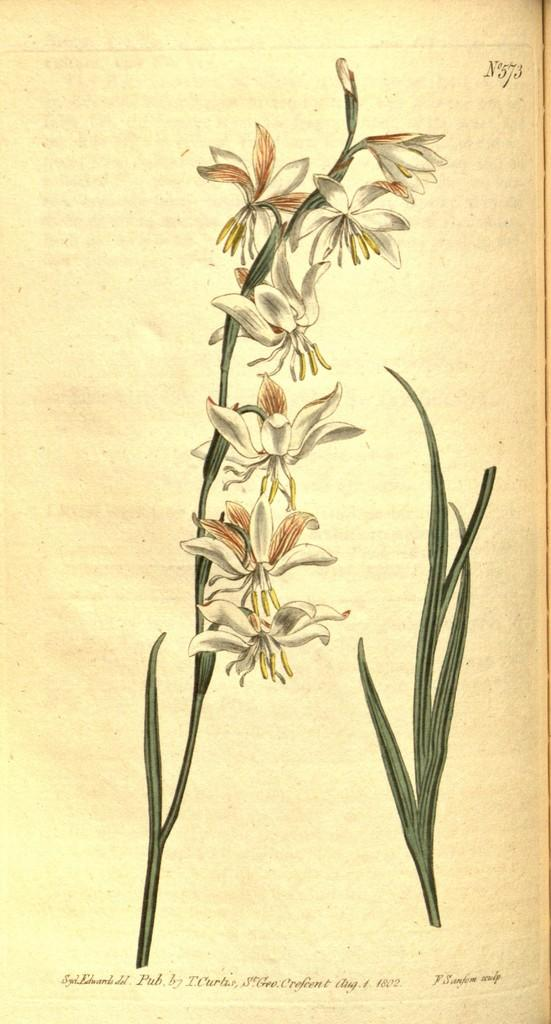What is present on the paper in the image? There is writing on the paper in the image. What other objects can be seen in the image? There is a plant and flowers in the image. What type of wing is visible on the plant in the image? There is no wing visible on the plant in the image. Is there an army present in the image? There is no army present in the image. 